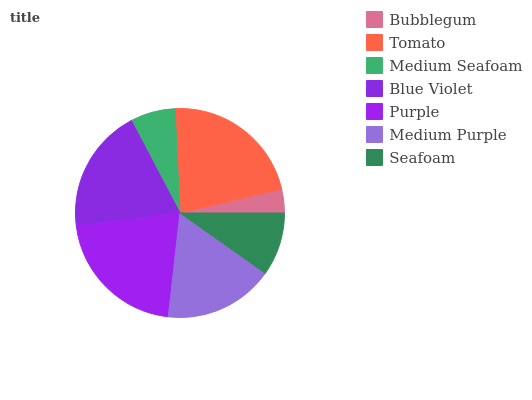Is Bubblegum the minimum?
Answer yes or no. Yes. Is Tomato the maximum?
Answer yes or no. Yes. Is Medium Seafoam the minimum?
Answer yes or no. No. Is Medium Seafoam the maximum?
Answer yes or no. No. Is Tomato greater than Medium Seafoam?
Answer yes or no. Yes. Is Medium Seafoam less than Tomato?
Answer yes or no. Yes. Is Medium Seafoam greater than Tomato?
Answer yes or no. No. Is Tomato less than Medium Seafoam?
Answer yes or no. No. Is Medium Purple the high median?
Answer yes or no. Yes. Is Medium Purple the low median?
Answer yes or no. Yes. Is Purple the high median?
Answer yes or no. No. Is Blue Violet the low median?
Answer yes or no. No. 